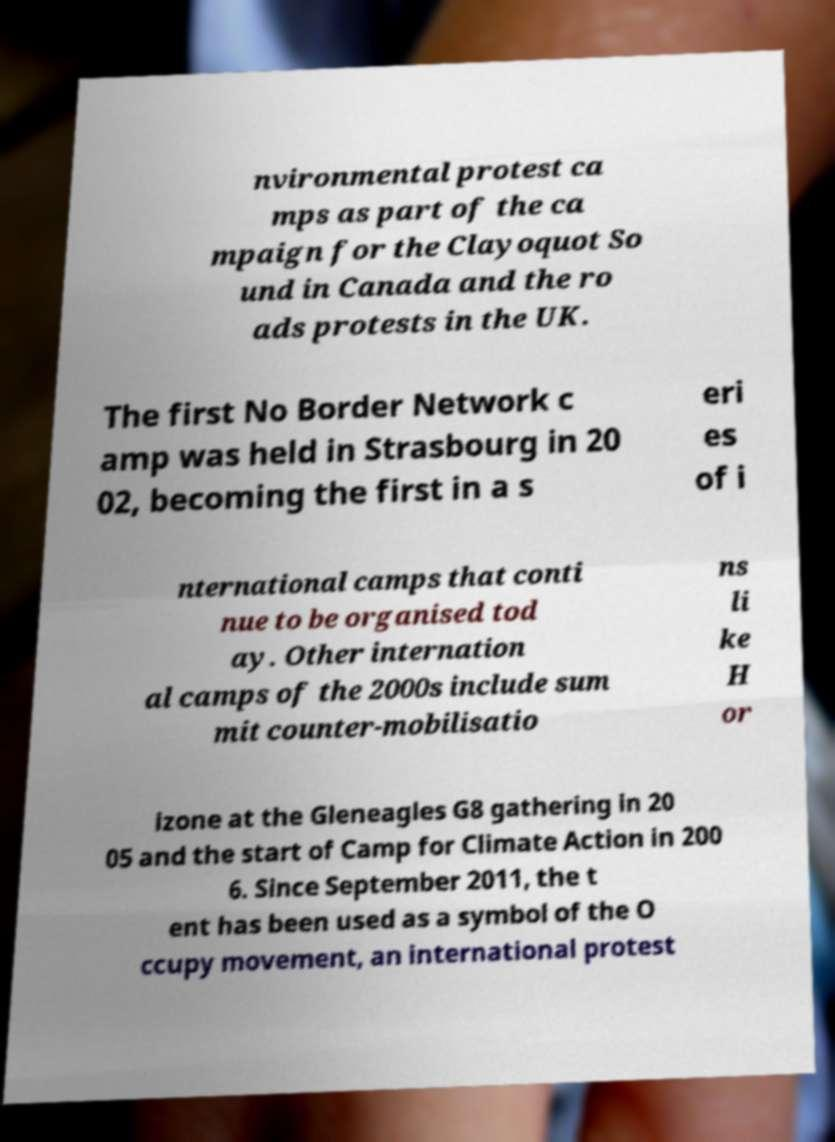I need the written content from this picture converted into text. Can you do that? nvironmental protest ca mps as part of the ca mpaign for the Clayoquot So und in Canada and the ro ads protests in the UK. The first No Border Network c amp was held in Strasbourg in 20 02, becoming the first in a s eri es of i nternational camps that conti nue to be organised tod ay. Other internation al camps of the 2000s include sum mit counter-mobilisatio ns li ke H or izone at the Gleneagles G8 gathering in 20 05 and the start of Camp for Climate Action in 200 6. Since September 2011, the t ent has been used as a symbol of the O ccupy movement, an international protest 